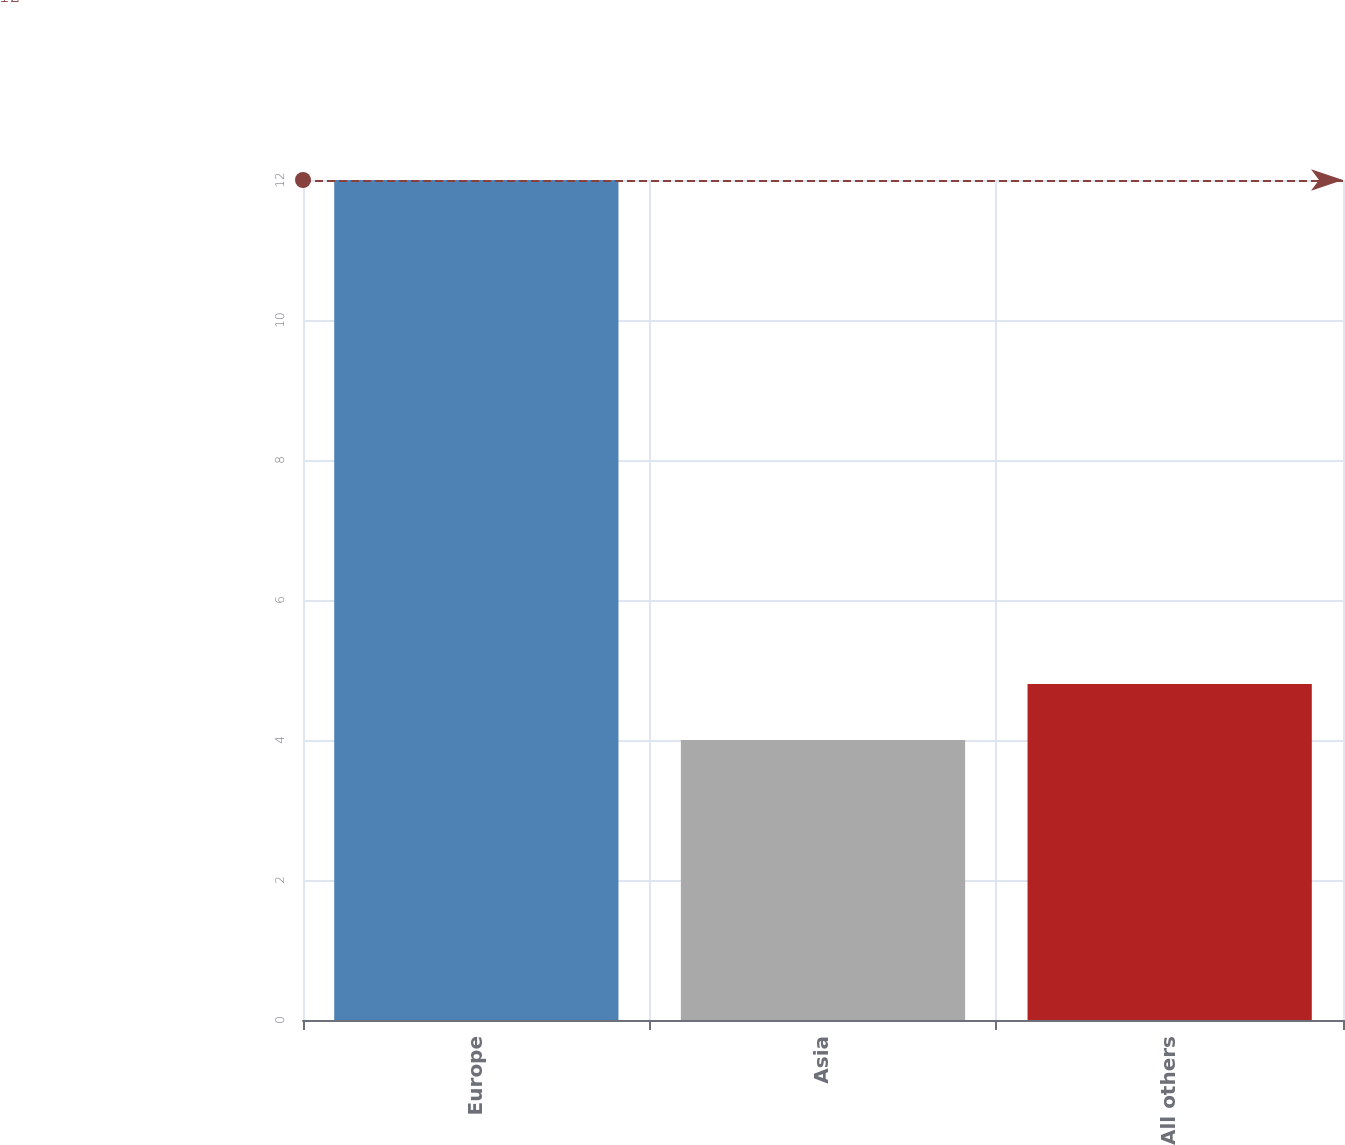<chart> <loc_0><loc_0><loc_500><loc_500><bar_chart><fcel>Europe<fcel>Asia<fcel>All others<nl><fcel>12<fcel>4<fcel>4.8<nl></chart> 